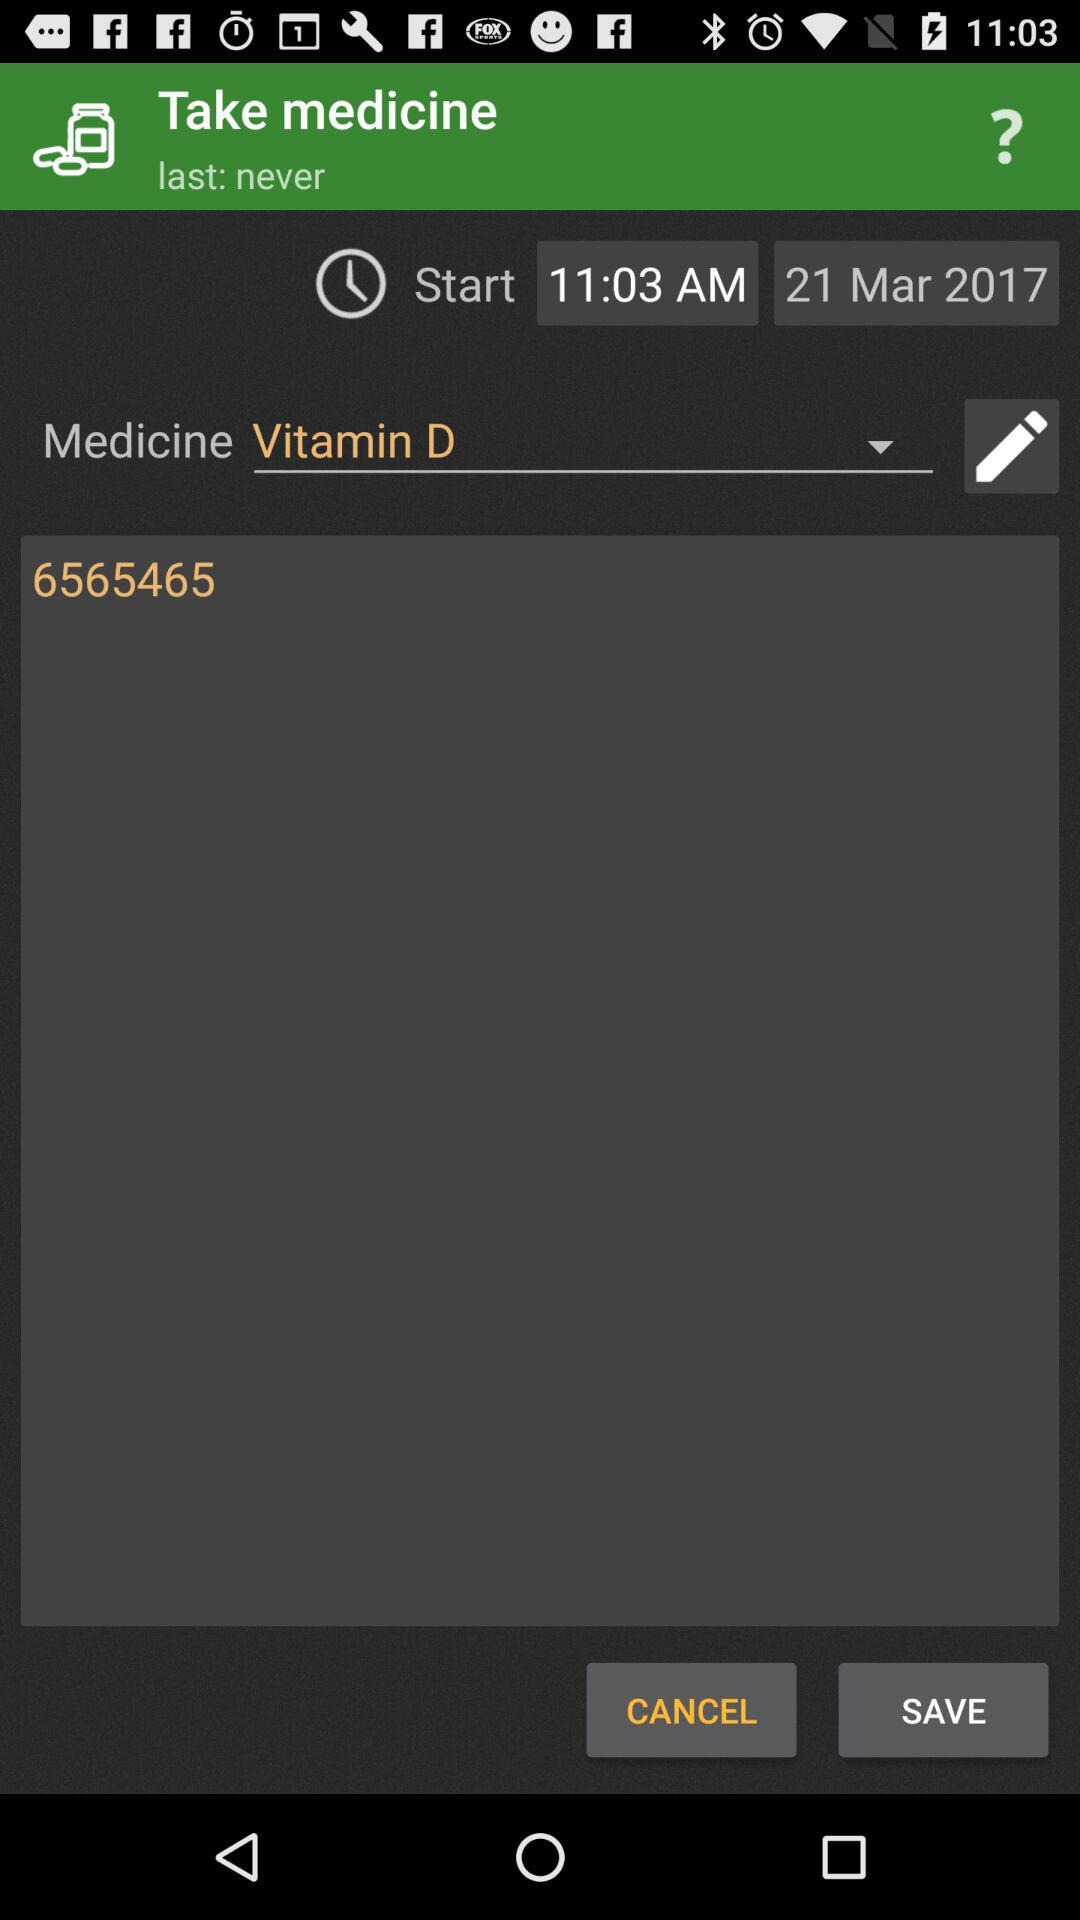What type of medicine is it? The type of medicine is vitamin D. 